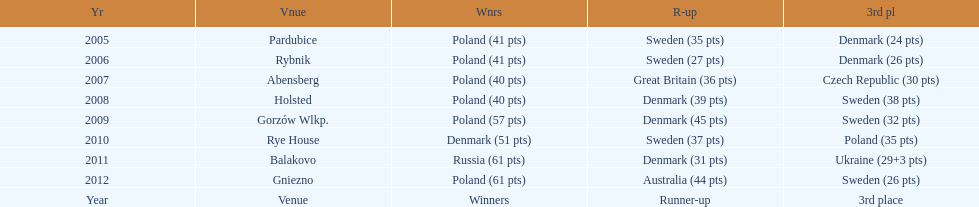From 2005-2012, in the team speedway junior world championship, how many more first place wins than all other teams put together? Poland. 